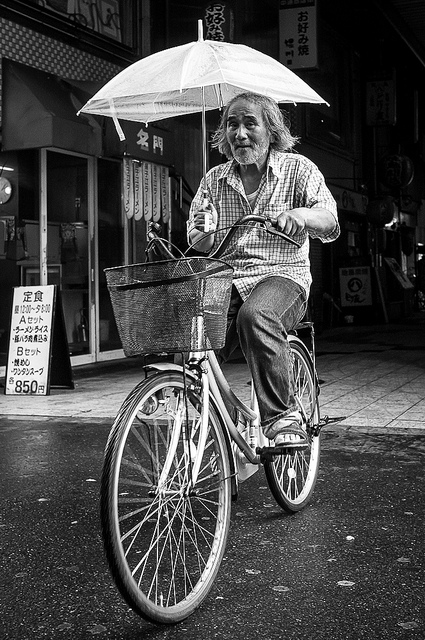<image>What is the jug the man is carrying? I don't know what the jug the man is carrying contains. It could be water, milk, alcohol, coffee, or even a thermos. What is the jug the man is carrying? I don't know what is the jug the man is carrying. It can be water, milk, umbrella, alcohol, coffee or thermos. 